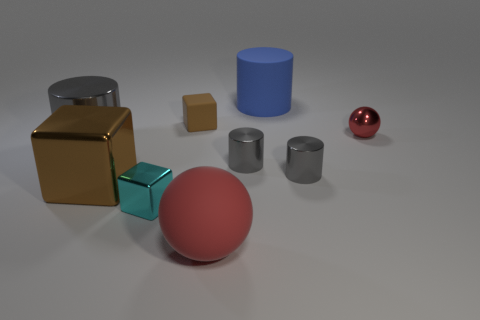There is a blue cylinder; are there any red things to the right of it?
Offer a terse response. Yes. Is the material of the big cylinder to the left of the cyan metal object the same as the large block behind the large red rubber object?
Give a very brief answer. Yes. What number of yellow rubber cubes are the same size as the metallic ball?
Provide a succinct answer. 0. What is the shape of the small shiny thing that is the same color as the rubber sphere?
Your response must be concise. Sphere. What is the red ball on the left side of the big blue object made of?
Give a very brief answer. Rubber. How many tiny shiny things are the same shape as the big red object?
Make the answer very short. 1. The brown thing that is made of the same material as the big red sphere is what shape?
Your answer should be compact. Cube. What shape is the large object in front of the brown thing that is on the left side of the tiny block behind the small metal cube?
Provide a short and direct response. Sphere. Are there more large green shiny balls than small shiny cylinders?
Offer a very short reply. No. What material is the other big object that is the same shape as the big blue rubber thing?
Your answer should be very brief. Metal. 